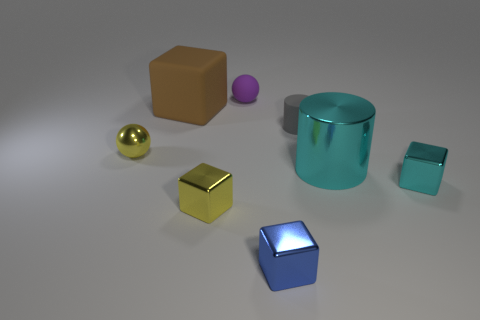How big is the metallic object that is both right of the rubber ball and to the left of the metal cylinder?
Provide a succinct answer. Small. Do the cyan metallic object that is right of the large cylinder and the large thing left of the tiny yellow metallic block have the same shape?
Ensure brevity in your answer.  Yes. What is the shape of the shiny object that is the same color as the metal cylinder?
Keep it short and to the point. Cube. How many yellow blocks have the same material as the gray cylinder?
Your answer should be very brief. 0. There is a rubber thing that is behind the rubber cylinder and in front of the rubber ball; what shape is it?
Your response must be concise. Cube. Does the small yellow thing that is on the right side of the large brown cube have the same material as the large cyan cylinder?
Offer a terse response. Yes. Is there any other thing that is made of the same material as the brown object?
Give a very brief answer. Yes. What color is the metallic sphere that is the same size as the blue metal thing?
Make the answer very short. Yellow. Is there a block of the same color as the tiny shiny sphere?
Your response must be concise. Yes. What is the size of the gray cylinder that is made of the same material as the purple thing?
Your response must be concise. Small. 